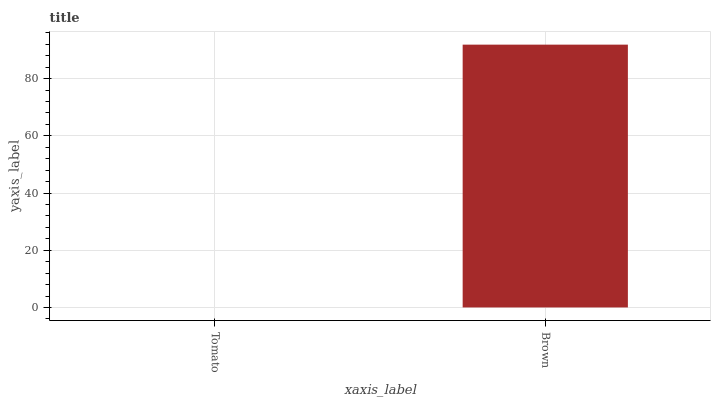Is Tomato the minimum?
Answer yes or no. Yes. Is Brown the maximum?
Answer yes or no. Yes. Is Brown the minimum?
Answer yes or no. No. Is Brown greater than Tomato?
Answer yes or no. Yes. Is Tomato less than Brown?
Answer yes or no. Yes. Is Tomato greater than Brown?
Answer yes or no. No. Is Brown less than Tomato?
Answer yes or no. No. Is Brown the high median?
Answer yes or no. Yes. Is Tomato the low median?
Answer yes or no. Yes. Is Tomato the high median?
Answer yes or no. No. Is Brown the low median?
Answer yes or no. No. 